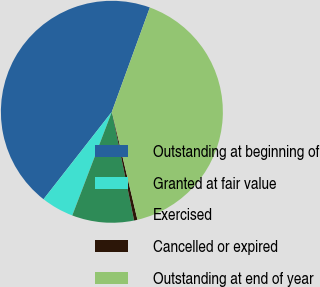Convert chart. <chart><loc_0><loc_0><loc_500><loc_500><pie_chart><fcel>Outstanding at beginning of<fcel>Granted at fair value<fcel>Exercised<fcel>Cancelled or expired<fcel>Outstanding at end of year<nl><fcel>45.0%<fcel>4.75%<fcel>9.02%<fcel>0.49%<fcel>40.74%<nl></chart> 